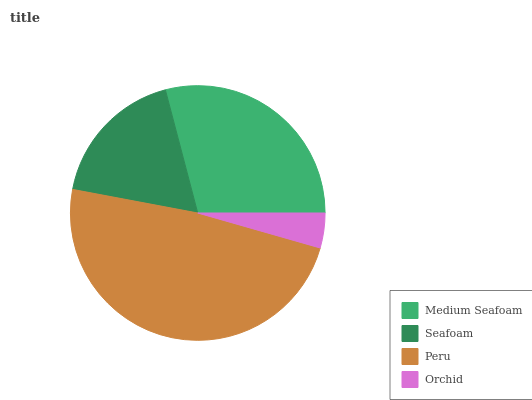Is Orchid the minimum?
Answer yes or no. Yes. Is Peru the maximum?
Answer yes or no. Yes. Is Seafoam the minimum?
Answer yes or no. No. Is Seafoam the maximum?
Answer yes or no. No. Is Medium Seafoam greater than Seafoam?
Answer yes or no. Yes. Is Seafoam less than Medium Seafoam?
Answer yes or no. Yes. Is Seafoam greater than Medium Seafoam?
Answer yes or no. No. Is Medium Seafoam less than Seafoam?
Answer yes or no. No. Is Medium Seafoam the high median?
Answer yes or no. Yes. Is Seafoam the low median?
Answer yes or no. Yes. Is Orchid the high median?
Answer yes or no. No. Is Orchid the low median?
Answer yes or no. No. 